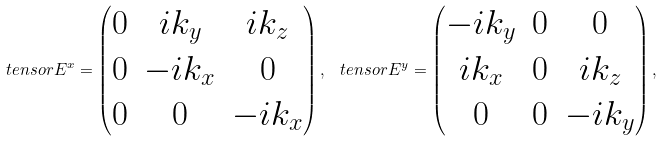Convert formula to latex. <formula><loc_0><loc_0><loc_500><loc_500>\ t e n s o r { E } ^ { x } = \begin{pmatrix} 0 & i k _ { y } & i k _ { z } \\ 0 & - i k _ { x } & 0 \\ 0 & 0 & - i k _ { x } \end{pmatrix} , \, \ t e n s o r { E } ^ { y } = \begin{pmatrix} - i k _ { y } & 0 & 0 \\ i k _ { x } & 0 & i k _ { z } \\ 0 & 0 & - i k _ { y } \end{pmatrix} , \,</formula> 